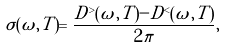<formula> <loc_0><loc_0><loc_500><loc_500>\sigma ( \omega , T ) = \frac { D ^ { > } ( \omega , T ) - D ^ { < } ( \omega , T ) } { 2 \pi } ,</formula> 